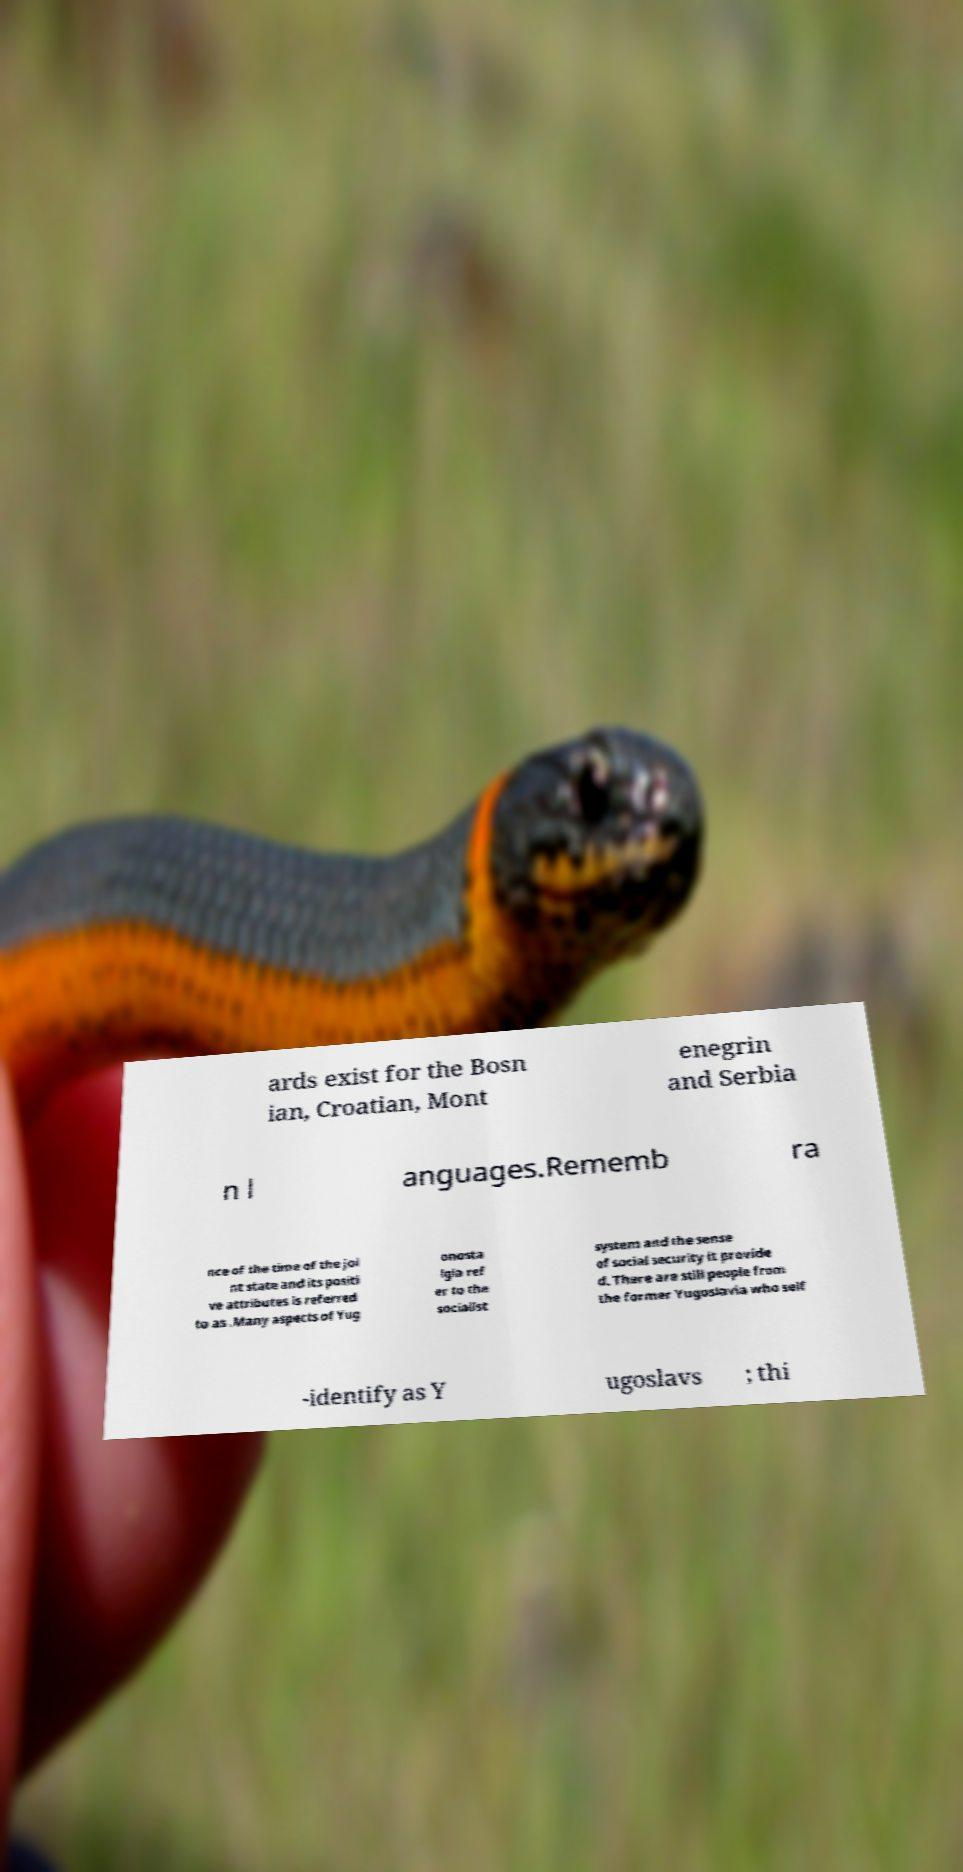Could you extract and type out the text from this image? ards exist for the Bosn ian, Croatian, Mont enegrin and Serbia n l anguages.Rememb ra nce of the time of the joi nt state and its positi ve attributes is referred to as .Many aspects of Yug onosta lgia ref er to the socialist system and the sense of social security it provide d. There are still people from the former Yugoslavia who self -identify as Y ugoslavs ; thi 